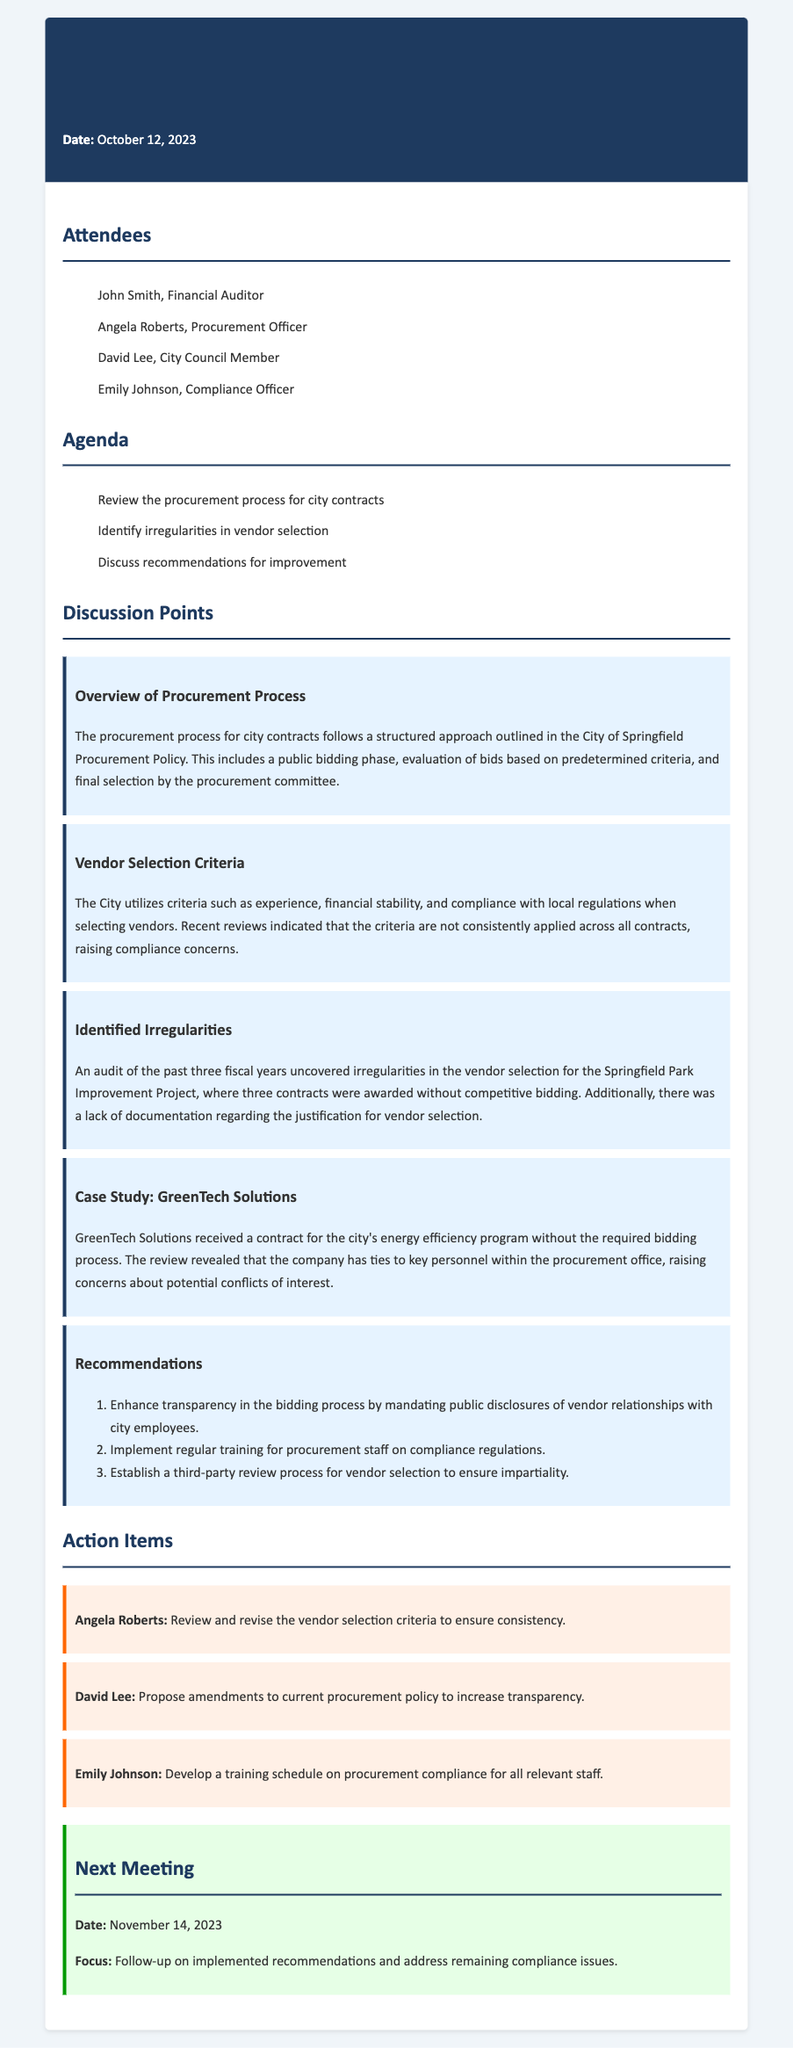What date was the meeting held? The date of the meeting is provided in the header of the document, which states October 12, 2023.
Answer: October 12, 2023 Who is the Procurement Officer? The attendees section lists Angela Roberts as the Procurement Officer.
Answer: Angela Roberts What was identified as a key issue in the vendor selection process? In the discussion points, it is noted that the vendor selection criteria are not consistently applied, which raises compliance concerns.
Answer: Compliance concerns What specific project was mentioned regarding identified irregularities? The document references the Springfield Park Improvement Project when discussing irregularities in vendor selection.
Answer: Springfield Park Improvement Project How many contracts were awarded without competitive bidding? The document states that three contracts were awarded without competitive bidding for the Springfield Park Improvement Project.
Answer: Three What is one of the recommendations made in the meeting? One of the recommendations is to enhance transparency in the bidding process by mandating public disclosures of vendor relationships with city employees.
Answer: Enhance transparency in the bidding process Who is responsible for developing a training schedule on procurement compliance? The action items specify that Emily Johnson is tasked with developing a training schedule on procurement compliance for all relevant staff.
Answer: Emily Johnson When is the next meeting scheduled? The next meeting date is listed at the end of the document, stating November 14, 2023.
Answer: November 14, 2023 What is a concern raised regarding GreenTech Solutions? The discussion mentions that GreenTech Solutions received a contract without the required bidding process due to ties with key personnel within the procurement office.
Answer: Potential conflicts of interest 